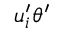Convert formula to latex. <formula><loc_0><loc_0><loc_500><loc_500>u _ { i } ^ { \prime } \theta ^ { \prime }</formula> 